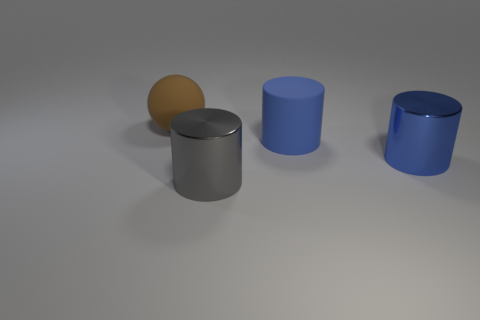Add 3 big gray shiny cylinders. How many objects exist? 7 Subtract all balls. How many objects are left? 3 Add 4 big balls. How many big balls are left? 5 Add 4 big green metallic cylinders. How many big green metallic cylinders exist? 4 Subtract 0 brown cubes. How many objects are left? 4 Subtract all brown metallic blocks. Subtract all brown rubber things. How many objects are left? 3 